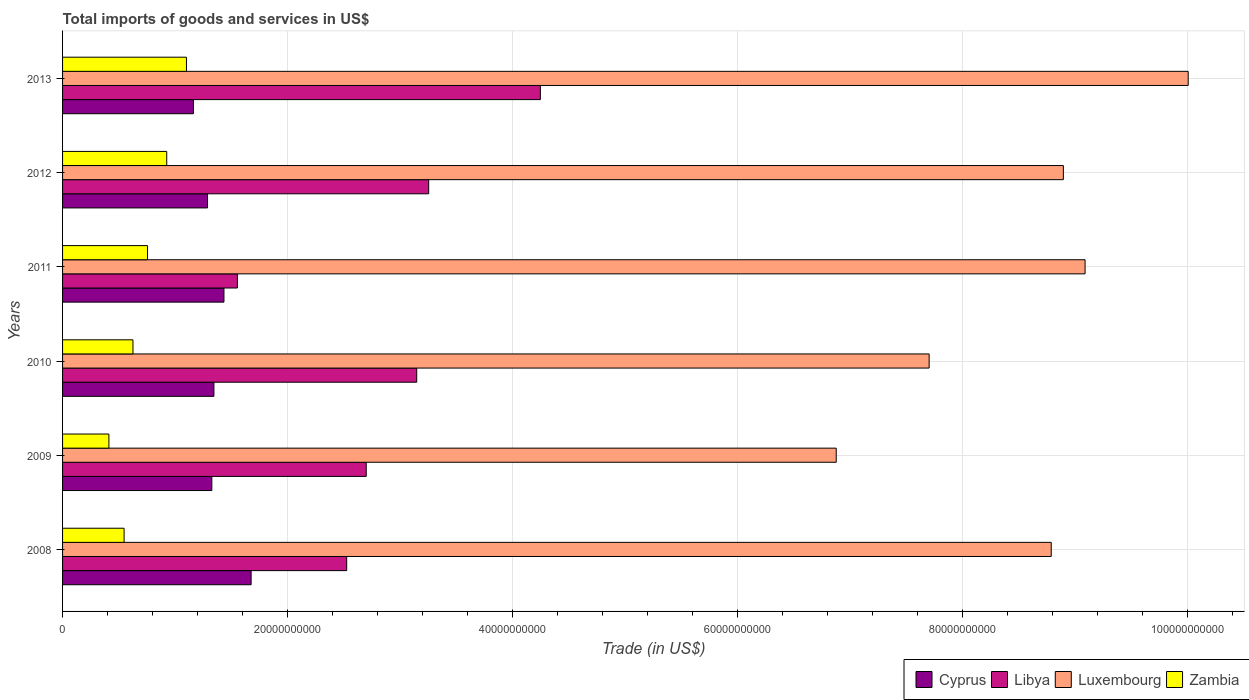Are the number of bars per tick equal to the number of legend labels?
Offer a terse response. Yes. Are the number of bars on each tick of the Y-axis equal?
Provide a succinct answer. Yes. How many bars are there on the 3rd tick from the top?
Provide a succinct answer. 4. In how many cases, is the number of bars for a given year not equal to the number of legend labels?
Offer a very short reply. 0. What is the total imports of goods and services in Luxembourg in 2008?
Give a very brief answer. 8.79e+1. Across all years, what is the maximum total imports of goods and services in Luxembourg?
Provide a short and direct response. 1.00e+11. Across all years, what is the minimum total imports of goods and services in Luxembourg?
Ensure brevity in your answer.  6.88e+1. What is the total total imports of goods and services in Libya in the graph?
Offer a very short reply. 1.74e+11. What is the difference between the total imports of goods and services in Zambia in 2010 and that in 2012?
Offer a very short reply. -3.00e+09. What is the difference between the total imports of goods and services in Luxembourg in 2008 and the total imports of goods and services in Cyprus in 2013?
Give a very brief answer. 7.62e+1. What is the average total imports of goods and services in Cyprus per year?
Offer a very short reply. 1.37e+1. In the year 2011, what is the difference between the total imports of goods and services in Zambia and total imports of goods and services in Cyprus?
Provide a short and direct response. -6.79e+09. What is the ratio of the total imports of goods and services in Luxembourg in 2008 to that in 2011?
Give a very brief answer. 0.97. Is the difference between the total imports of goods and services in Zambia in 2011 and 2012 greater than the difference between the total imports of goods and services in Cyprus in 2011 and 2012?
Your answer should be very brief. No. What is the difference between the highest and the second highest total imports of goods and services in Cyprus?
Give a very brief answer. 2.41e+09. What is the difference between the highest and the lowest total imports of goods and services in Libya?
Keep it short and to the point. 2.69e+1. In how many years, is the total imports of goods and services in Luxembourg greater than the average total imports of goods and services in Luxembourg taken over all years?
Give a very brief answer. 4. What does the 4th bar from the top in 2008 represents?
Offer a terse response. Cyprus. What does the 2nd bar from the bottom in 2013 represents?
Make the answer very short. Libya. Is it the case that in every year, the sum of the total imports of goods and services in Libya and total imports of goods and services in Luxembourg is greater than the total imports of goods and services in Zambia?
Your answer should be compact. Yes. How many bars are there?
Your answer should be compact. 24. Are all the bars in the graph horizontal?
Provide a short and direct response. Yes. What is the difference between two consecutive major ticks on the X-axis?
Give a very brief answer. 2.00e+1. Does the graph contain any zero values?
Offer a very short reply. No. Does the graph contain grids?
Ensure brevity in your answer.  Yes. How are the legend labels stacked?
Provide a short and direct response. Horizontal. What is the title of the graph?
Provide a short and direct response. Total imports of goods and services in US$. What is the label or title of the X-axis?
Your answer should be compact. Trade (in US$). What is the label or title of the Y-axis?
Give a very brief answer. Years. What is the Trade (in US$) in Cyprus in 2008?
Offer a very short reply. 1.68e+1. What is the Trade (in US$) of Libya in 2008?
Make the answer very short. 2.53e+1. What is the Trade (in US$) of Luxembourg in 2008?
Your response must be concise. 8.79e+1. What is the Trade (in US$) in Zambia in 2008?
Keep it short and to the point. 5.47e+09. What is the Trade (in US$) in Cyprus in 2009?
Ensure brevity in your answer.  1.33e+1. What is the Trade (in US$) in Libya in 2009?
Provide a short and direct response. 2.70e+1. What is the Trade (in US$) in Luxembourg in 2009?
Your response must be concise. 6.88e+1. What is the Trade (in US$) of Zambia in 2009?
Make the answer very short. 4.12e+09. What is the Trade (in US$) of Cyprus in 2010?
Provide a short and direct response. 1.35e+1. What is the Trade (in US$) in Libya in 2010?
Offer a very short reply. 3.15e+1. What is the Trade (in US$) of Luxembourg in 2010?
Your response must be concise. 7.70e+1. What is the Trade (in US$) of Zambia in 2010?
Provide a short and direct response. 6.26e+09. What is the Trade (in US$) of Cyprus in 2011?
Make the answer very short. 1.43e+1. What is the Trade (in US$) of Libya in 2011?
Your answer should be compact. 1.55e+1. What is the Trade (in US$) in Luxembourg in 2011?
Your answer should be compact. 9.09e+1. What is the Trade (in US$) in Zambia in 2011?
Keep it short and to the point. 7.55e+09. What is the Trade (in US$) in Cyprus in 2012?
Provide a succinct answer. 1.29e+1. What is the Trade (in US$) in Libya in 2012?
Offer a very short reply. 3.25e+1. What is the Trade (in US$) in Luxembourg in 2012?
Provide a succinct answer. 8.90e+1. What is the Trade (in US$) of Zambia in 2012?
Your response must be concise. 9.26e+09. What is the Trade (in US$) of Cyprus in 2013?
Offer a terse response. 1.16e+1. What is the Trade (in US$) of Libya in 2013?
Provide a succinct answer. 4.25e+1. What is the Trade (in US$) of Luxembourg in 2013?
Ensure brevity in your answer.  1.00e+11. What is the Trade (in US$) in Zambia in 2013?
Offer a very short reply. 1.10e+1. Across all years, what is the maximum Trade (in US$) of Cyprus?
Keep it short and to the point. 1.68e+1. Across all years, what is the maximum Trade (in US$) in Libya?
Your answer should be very brief. 4.25e+1. Across all years, what is the maximum Trade (in US$) of Luxembourg?
Make the answer very short. 1.00e+11. Across all years, what is the maximum Trade (in US$) in Zambia?
Make the answer very short. 1.10e+1. Across all years, what is the minimum Trade (in US$) in Cyprus?
Your answer should be compact. 1.16e+1. Across all years, what is the minimum Trade (in US$) of Libya?
Offer a terse response. 1.55e+1. Across all years, what is the minimum Trade (in US$) in Luxembourg?
Offer a terse response. 6.88e+1. Across all years, what is the minimum Trade (in US$) in Zambia?
Your answer should be compact. 4.12e+09. What is the total Trade (in US$) in Cyprus in the graph?
Your response must be concise. 8.23e+1. What is the total Trade (in US$) of Libya in the graph?
Provide a short and direct response. 1.74e+11. What is the total Trade (in US$) of Luxembourg in the graph?
Offer a very short reply. 5.14e+11. What is the total Trade (in US$) in Zambia in the graph?
Offer a terse response. 4.37e+1. What is the difference between the Trade (in US$) in Cyprus in 2008 and that in 2009?
Your answer should be compact. 3.49e+09. What is the difference between the Trade (in US$) of Libya in 2008 and that in 2009?
Provide a short and direct response. -1.74e+09. What is the difference between the Trade (in US$) in Luxembourg in 2008 and that in 2009?
Provide a succinct answer. 1.91e+1. What is the difference between the Trade (in US$) in Zambia in 2008 and that in 2009?
Your answer should be compact. 1.35e+09. What is the difference between the Trade (in US$) of Cyprus in 2008 and that in 2010?
Your answer should be very brief. 3.31e+09. What is the difference between the Trade (in US$) of Libya in 2008 and that in 2010?
Make the answer very short. -6.22e+09. What is the difference between the Trade (in US$) of Luxembourg in 2008 and that in 2010?
Your answer should be compact. 1.09e+1. What is the difference between the Trade (in US$) in Zambia in 2008 and that in 2010?
Your answer should be very brief. -7.88e+08. What is the difference between the Trade (in US$) in Cyprus in 2008 and that in 2011?
Offer a terse response. 2.41e+09. What is the difference between the Trade (in US$) in Libya in 2008 and that in 2011?
Provide a succinct answer. 9.71e+09. What is the difference between the Trade (in US$) of Luxembourg in 2008 and that in 2011?
Offer a very short reply. -3.01e+09. What is the difference between the Trade (in US$) in Zambia in 2008 and that in 2011?
Ensure brevity in your answer.  -2.08e+09. What is the difference between the Trade (in US$) of Cyprus in 2008 and that in 2012?
Your answer should be very brief. 3.87e+09. What is the difference between the Trade (in US$) of Libya in 2008 and that in 2012?
Give a very brief answer. -7.29e+09. What is the difference between the Trade (in US$) of Luxembourg in 2008 and that in 2012?
Offer a terse response. -1.08e+09. What is the difference between the Trade (in US$) in Zambia in 2008 and that in 2012?
Give a very brief answer. -3.79e+09. What is the difference between the Trade (in US$) of Cyprus in 2008 and that in 2013?
Your answer should be very brief. 5.13e+09. What is the difference between the Trade (in US$) of Libya in 2008 and that in 2013?
Your response must be concise. -1.72e+1. What is the difference between the Trade (in US$) of Luxembourg in 2008 and that in 2013?
Keep it short and to the point. -1.22e+1. What is the difference between the Trade (in US$) of Zambia in 2008 and that in 2013?
Your answer should be very brief. -5.54e+09. What is the difference between the Trade (in US$) of Cyprus in 2009 and that in 2010?
Make the answer very short. -1.86e+08. What is the difference between the Trade (in US$) of Libya in 2009 and that in 2010?
Provide a succinct answer. -4.49e+09. What is the difference between the Trade (in US$) of Luxembourg in 2009 and that in 2010?
Provide a short and direct response. -8.26e+09. What is the difference between the Trade (in US$) of Zambia in 2009 and that in 2010?
Keep it short and to the point. -2.14e+09. What is the difference between the Trade (in US$) of Cyprus in 2009 and that in 2011?
Offer a very short reply. -1.08e+09. What is the difference between the Trade (in US$) of Libya in 2009 and that in 2011?
Your answer should be compact. 1.14e+1. What is the difference between the Trade (in US$) of Luxembourg in 2009 and that in 2011?
Provide a succinct answer. -2.21e+1. What is the difference between the Trade (in US$) of Zambia in 2009 and that in 2011?
Offer a terse response. -3.43e+09. What is the difference between the Trade (in US$) of Cyprus in 2009 and that in 2012?
Ensure brevity in your answer.  3.82e+08. What is the difference between the Trade (in US$) of Libya in 2009 and that in 2012?
Provide a short and direct response. -5.55e+09. What is the difference between the Trade (in US$) of Luxembourg in 2009 and that in 2012?
Offer a terse response. -2.02e+1. What is the difference between the Trade (in US$) of Zambia in 2009 and that in 2012?
Give a very brief answer. -5.14e+09. What is the difference between the Trade (in US$) in Cyprus in 2009 and that in 2013?
Provide a short and direct response. 1.64e+09. What is the difference between the Trade (in US$) of Libya in 2009 and that in 2013?
Offer a terse response. -1.55e+1. What is the difference between the Trade (in US$) in Luxembourg in 2009 and that in 2013?
Your response must be concise. -3.13e+1. What is the difference between the Trade (in US$) of Zambia in 2009 and that in 2013?
Offer a terse response. -6.89e+09. What is the difference between the Trade (in US$) in Cyprus in 2010 and that in 2011?
Your response must be concise. -8.92e+08. What is the difference between the Trade (in US$) in Libya in 2010 and that in 2011?
Keep it short and to the point. 1.59e+1. What is the difference between the Trade (in US$) of Luxembourg in 2010 and that in 2011?
Ensure brevity in your answer.  -1.39e+1. What is the difference between the Trade (in US$) in Zambia in 2010 and that in 2011?
Provide a short and direct response. -1.30e+09. What is the difference between the Trade (in US$) of Cyprus in 2010 and that in 2012?
Your response must be concise. 5.68e+08. What is the difference between the Trade (in US$) in Libya in 2010 and that in 2012?
Provide a short and direct response. -1.06e+09. What is the difference between the Trade (in US$) in Luxembourg in 2010 and that in 2012?
Your answer should be very brief. -1.19e+1. What is the difference between the Trade (in US$) of Zambia in 2010 and that in 2012?
Give a very brief answer. -3.00e+09. What is the difference between the Trade (in US$) of Cyprus in 2010 and that in 2013?
Make the answer very short. 1.82e+09. What is the difference between the Trade (in US$) in Libya in 2010 and that in 2013?
Your answer should be compact. -1.10e+1. What is the difference between the Trade (in US$) of Luxembourg in 2010 and that in 2013?
Offer a terse response. -2.30e+1. What is the difference between the Trade (in US$) in Zambia in 2010 and that in 2013?
Keep it short and to the point. -4.75e+09. What is the difference between the Trade (in US$) of Cyprus in 2011 and that in 2012?
Keep it short and to the point. 1.46e+09. What is the difference between the Trade (in US$) of Libya in 2011 and that in 2012?
Offer a very short reply. -1.70e+1. What is the difference between the Trade (in US$) of Luxembourg in 2011 and that in 2012?
Offer a very short reply. 1.93e+09. What is the difference between the Trade (in US$) in Zambia in 2011 and that in 2012?
Make the answer very short. -1.71e+09. What is the difference between the Trade (in US$) in Cyprus in 2011 and that in 2013?
Ensure brevity in your answer.  2.71e+09. What is the difference between the Trade (in US$) of Libya in 2011 and that in 2013?
Your answer should be compact. -2.69e+1. What is the difference between the Trade (in US$) in Luxembourg in 2011 and that in 2013?
Your answer should be very brief. -9.17e+09. What is the difference between the Trade (in US$) in Zambia in 2011 and that in 2013?
Your answer should be very brief. -3.46e+09. What is the difference between the Trade (in US$) in Cyprus in 2012 and that in 2013?
Provide a succinct answer. 1.25e+09. What is the difference between the Trade (in US$) in Libya in 2012 and that in 2013?
Your answer should be compact. -9.93e+09. What is the difference between the Trade (in US$) of Luxembourg in 2012 and that in 2013?
Provide a succinct answer. -1.11e+1. What is the difference between the Trade (in US$) of Zambia in 2012 and that in 2013?
Keep it short and to the point. -1.75e+09. What is the difference between the Trade (in US$) in Cyprus in 2008 and the Trade (in US$) in Libya in 2009?
Your response must be concise. -1.02e+1. What is the difference between the Trade (in US$) in Cyprus in 2008 and the Trade (in US$) in Luxembourg in 2009?
Provide a short and direct response. -5.20e+1. What is the difference between the Trade (in US$) in Cyprus in 2008 and the Trade (in US$) in Zambia in 2009?
Your answer should be very brief. 1.26e+1. What is the difference between the Trade (in US$) of Libya in 2008 and the Trade (in US$) of Luxembourg in 2009?
Give a very brief answer. -4.35e+1. What is the difference between the Trade (in US$) in Libya in 2008 and the Trade (in US$) in Zambia in 2009?
Give a very brief answer. 2.11e+1. What is the difference between the Trade (in US$) in Luxembourg in 2008 and the Trade (in US$) in Zambia in 2009?
Keep it short and to the point. 8.38e+1. What is the difference between the Trade (in US$) in Cyprus in 2008 and the Trade (in US$) in Libya in 2010?
Your response must be concise. -1.47e+1. What is the difference between the Trade (in US$) in Cyprus in 2008 and the Trade (in US$) in Luxembourg in 2010?
Your response must be concise. -6.03e+1. What is the difference between the Trade (in US$) of Cyprus in 2008 and the Trade (in US$) of Zambia in 2010?
Your answer should be very brief. 1.05e+1. What is the difference between the Trade (in US$) in Libya in 2008 and the Trade (in US$) in Luxembourg in 2010?
Your answer should be very brief. -5.18e+1. What is the difference between the Trade (in US$) in Libya in 2008 and the Trade (in US$) in Zambia in 2010?
Ensure brevity in your answer.  1.90e+1. What is the difference between the Trade (in US$) in Luxembourg in 2008 and the Trade (in US$) in Zambia in 2010?
Offer a terse response. 8.16e+1. What is the difference between the Trade (in US$) of Cyprus in 2008 and the Trade (in US$) of Libya in 2011?
Your answer should be very brief. 1.22e+09. What is the difference between the Trade (in US$) in Cyprus in 2008 and the Trade (in US$) in Luxembourg in 2011?
Provide a succinct answer. -7.41e+1. What is the difference between the Trade (in US$) of Cyprus in 2008 and the Trade (in US$) of Zambia in 2011?
Offer a very short reply. 9.21e+09. What is the difference between the Trade (in US$) of Libya in 2008 and the Trade (in US$) of Luxembourg in 2011?
Your answer should be compact. -6.56e+1. What is the difference between the Trade (in US$) of Libya in 2008 and the Trade (in US$) of Zambia in 2011?
Provide a succinct answer. 1.77e+1. What is the difference between the Trade (in US$) in Luxembourg in 2008 and the Trade (in US$) in Zambia in 2011?
Your answer should be compact. 8.03e+1. What is the difference between the Trade (in US$) of Cyprus in 2008 and the Trade (in US$) of Libya in 2012?
Offer a very short reply. -1.58e+1. What is the difference between the Trade (in US$) of Cyprus in 2008 and the Trade (in US$) of Luxembourg in 2012?
Keep it short and to the point. -7.22e+1. What is the difference between the Trade (in US$) of Cyprus in 2008 and the Trade (in US$) of Zambia in 2012?
Provide a short and direct response. 7.50e+09. What is the difference between the Trade (in US$) in Libya in 2008 and the Trade (in US$) in Luxembourg in 2012?
Offer a very short reply. -6.37e+1. What is the difference between the Trade (in US$) of Libya in 2008 and the Trade (in US$) of Zambia in 2012?
Keep it short and to the point. 1.60e+1. What is the difference between the Trade (in US$) of Luxembourg in 2008 and the Trade (in US$) of Zambia in 2012?
Give a very brief answer. 7.86e+1. What is the difference between the Trade (in US$) of Cyprus in 2008 and the Trade (in US$) of Libya in 2013?
Offer a terse response. -2.57e+1. What is the difference between the Trade (in US$) in Cyprus in 2008 and the Trade (in US$) in Luxembourg in 2013?
Keep it short and to the point. -8.33e+1. What is the difference between the Trade (in US$) of Cyprus in 2008 and the Trade (in US$) of Zambia in 2013?
Ensure brevity in your answer.  5.75e+09. What is the difference between the Trade (in US$) of Libya in 2008 and the Trade (in US$) of Luxembourg in 2013?
Your answer should be compact. -7.48e+1. What is the difference between the Trade (in US$) of Libya in 2008 and the Trade (in US$) of Zambia in 2013?
Give a very brief answer. 1.42e+1. What is the difference between the Trade (in US$) of Luxembourg in 2008 and the Trade (in US$) of Zambia in 2013?
Offer a very short reply. 7.69e+1. What is the difference between the Trade (in US$) of Cyprus in 2009 and the Trade (in US$) of Libya in 2010?
Provide a succinct answer. -1.82e+1. What is the difference between the Trade (in US$) in Cyprus in 2009 and the Trade (in US$) in Luxembourg in 2010?
Give a very brief answer. -6.38e+1. What is the difference between the Trade (in US$) in Cyprus in 2009 and the Trade (in US$) in Zambia in 2010?
Give a very brief answer. 7.01e+09. What is the difference between the Trade (in US$) of Libya in 2009 and the Trade (in US$) of Luxembourg in 2010?
Offer a very short reply. -5.00e+1. What is the difference between the Trade (in US$) of Libya in 2009 and the Trade (in US$) of Zambia in 2010?
Your answer should be very brief. 2.07e+1. What is the difference between the Trade (in US$) in Luxembourg in 2009 and the Trade (in US$) in Zambia in 2010?
Provide a succinct answer. 6.25e+1. What is the difference between the Trade (in US$) of Cyprus in 2009 and the Trade (in US$) of Libya in 2011?
Your answer should be very brief. -2.28e+09. What is the difference between the Trade (in US$) in Cyprus in 2009 and the Trade (in US$) in Luxembourg in 2011?
Provide a succinct answer. -7.76e+1. What is the difference between the Trade (in US$) of Cyprus in 2009 and the Trade (in US$) of Zambia in 2011?
Provide a succinct answer. 5.71e+09. What is the difference between the Trade (in US$) of Libya in 2009 and the Trade (in US$) of Luxembourg in 2011?
Make the answer very short. -6.39e+1. What is the difference between the Trade (in US$) of Libya in 2009 and the Trade (in US$) of Zambia in 2011?
Provide a succinct answer. 1.94e+1. What is the difference between the Trade (in US$) in Luxembourg in 2009 and the Trade (in US$) in Zambia in 2011?
Offer a terse response. 6.12e+1. What is the difference between the Trade (in US$) of Cyprus in 2009 and the Trade (in US$) of Libya in 2012?
Keep it short and to the point. -1.93e+1. What is the difference between the Trade (in US$) of Cyprus in 2009 and the Trade (in US$) of Luxembourg in 2012?
Your response must be concise. -7.57e+1. What is the difference between the Trade (in US$) in Cyprus in 2009 and the Trade (in US$) in Zambia in 2012?
Provide a succinct answer. 4.01e+09. What is the difference between the Trade (in US$) in Libya in 2009 and the Trade (in US$) in Luxembourg in 2012?
Your answer should be compact. -6.20e+1. What is the difference between the Trade (in US$) of Libya in 2009 and the Trade (in US$) of Zambia in 2012?
Offer a very short reply. 1.77e+1. What is the difference between the Trade (in US$) of Luxembourg in 2009 and the Trade (in US$) of Zambia in 2012?
Provide a short and direct response. 5.95e+1. What is the difference between the Trade (in US$) in Cyprus in 2009 and the Trade (in US$) in Libya in 2013?
Your answer should be very brief. -2.92e+1. What is the difference between the Trade (in US$) of Cyprus in 2009 and the Trade (in US$) of Luxembourg in 2013?
Your response must be concise. -8.68e+1. What is the difference between the Trade (in US$) of Cyprus in 2009 and the Trade (in US$) of Zambia in 2013?
Your response must be concise. 2.26e+09. What is the difference between the Trade (in US$) of Libya in 2009 and the Trade (in US$) of Luxembourg in 2013?
Keep it short and to the point. -7.31e+1. What is the difference between the Trade (in US$) in Libya in 2009 and the Trade (in US$) in Zambia in 2013?
Provide a succinct answer. 1.60e+1. What is the difference between the Trade (in US$) of Luxembourg in 2009 and the Trade (in US$) of Zambia in 2013?
Make the answer very short. 5.78e+1. What is the difference between the Trade (in US$) of Cyprus in 2010 and the Trade (in US$) of Libya in 2011?
Provide a short and direct response. -2.09e+09. What is the difference between the Trade (in US$) in Cyprus in 2010 and the Trade (in US$) in Luxembourg in 2011?
Provide a succinct answer. -7.74e+1. What is the difference between the Trade (in US$) of Cyprus in 2010 and the Trade (in US$) of Zambia in 2011?
Provide a short and direct response. 5.90e+09. What is the difference between the Trade (in US$) in Libya in 2010 and the Trade (in US$) in Luxembourg in 2011?
Provide a short and direct response. -5.94e+1. What is the difference between the Trade (in US$) in Libya in 2010 and the Trade (in US$) in Zambia in 2011?
Ensure brevity in your answer.  2.39e+1. What is the difference between the Trade (in US$) of Luxembourg in 2010 and the Trade (in US$) of Zambia in 2011?
Provide a short and direct response. 6.95e+1. What is the difference between the Trade (in US$) of Cyprus in 2010 and the Trade (in US$) of Libya in 2012?
Give a very brief answer. -1.91e+1. What is the difference between the Trade (in US$) of Cyprus in 2010 and the Trade (in US$) of Luxembourg in 2012?
Give a very brief answer. -7.55e+1. What is the difference between the Trade (in US$) of Cyprus in 2010 and the Trade (in US$) of Zambia in 2012?
Offer a terse response. 4.19e+09. What is the difference between the Trade (in US$) in Libya in 2010 and the Trade (in US$) in Luxembourg in 2012?
Give a very brief answer. -5.75e+1. What is the difference between the Trade (in US$) in Libya in 2010 and the Trade (in US$) in Zambia in 2012?
Your answer should be compact. 2.22e+1. What is the difference between the Trade (in US$) of Luxembourg in 2010 and the Trade (in US$) of Zambia in 2012?
Offer a very short reply. 6.78e+1. What is the difference between the Trade (in US$) of Cyprus in 2010 and the Trade (in US$) of Libya in 2013?
Offer a terse response. -2.90e+1. What is the difference between the Trade (in US$) in Cyprus in 2010 and the Trade (in US$) in Luxembourg in 2013?
Ensure brevity in your answer.  -8.66e+1. What is the difference between the Trade (in US$) in Cyprus in 2010 and the Trade (in US$) in Zambia in 2013?
Your answer should be very brief. 2.44e+09. What is the difference between the Trade (in US$) of Libya in 2010 and the Trade (in US$) of Luxembourg in 2013?
Give a very brief answer. -6.86e+1. What is the difference between the Trade (in US$) of Libya in 2010 and the Trade (in US$) of Zambia in 2013?
Offer a very short reply. 2.05e+1. What is the difference between the Trade (in US$) of Luxembourg in 2010 and the Trade (in US$) of Zambia in 2013?
Your answer should be very brief. 6.60e+1. What is the difference between the Trade (in US$) of Cyprus in 2011 and the Trade (in US$) of Libya in 2012?
Provide a short and direct response. -1.82e+1. What is the difference between the Trade (in US$) of Cyprus in 2011 and the Trade (in US$) of Luxembourg in 2012?
Your answer should be very brief. -7.46e+1. What is the difference between the Trade (in US$) in Cyprus in 2011 and the Trade (in US$) in Zambia in 2012?
Keep it short and to the point. 5.09e+09. What is the difference between the Trade (in US$) in Libya in 2011 and the Trade (in US$) in Luxembourg in 2012?
Ensure brevity in your answer.  -7.34e+1. What is the difference between the Trade (in US$) of Libya in 2011 and the Trade (in US$) of Zambia in 2012?
Your answer should be compact. 6.28e+09. What is the difference between the Trade (in US$) of Luxembourg in 2011 and the Trade (in US$) of Zambia in 2012?
Provide a short and direct response. 8.16e+1. What is the difference between the Trade (in US$) of Cyprus in 2011 and the Trade (in US$) of Libya in 2013?
Your answer should be compact. -2.81e+1. What is the difference between the Trade (in US$) of Cyprus in 2011 and the Trade (in US$) of Luxembourg in 2013?
Offer a terse response. -8.57e+1. What is the difference between the Trade (in US$) in Cyprus in 2011 and the Trade (in US$) in Zambia in 2013?
Ensure brevity in your answer.  3.33e+09. What is the difference between the Trade (in US$) of Libya in 2011 and the Trade (in US$) of Luxembourg in 2013?
Offer a terse response. -8.45e+1. What is the difference between the Trade (in US$) of Libya in 2011 and the Trade (in US$) of Zambia in 2013?
Your answer should be very brief. 4.53e+09. What is the difference between the Trade (in US$) in Luxembourg in 2011 and the Trade (in US$) in Zambia in 2013?
Keep it short and to the point. 7.99e+1. What is the difference between the Trade (in US$) in Cyprus in 2012 and the Trade (in US$) in Libya in 2013?
Keep it short and to the point. -2.96e+1. What is the difference between the Trade (in US$) in Cyprus in 2012 and the Trade (in US$) in Luxembourg in 2013?
Offer a terse response. -8.72e+1. What is the difference between the Trade (in US$) in Cyprus in 2012 and the Trade (in US$) in Zambia in 2013?
Provide a short and direct response. 1.87e+09. What is the difference between the Trade (in US$) in Libya in 2012 and the Trade (in US$) in Luxembourg in 2013?
Your answer should be very brief. -6.75e+1. What is the difference between the Trade (in US$) in Libya in 2012 and the Trade (in US$) in Zambia in 2013?
Your answer should be compact. 2.15e+1. What is the difference between the Trade (in US$) in Luxembourg in 2012 and the Trade (in US$) in Zambia in 2013?
Provide a succinct answer. 7.79e+1. What is the average Trade (in US$) of Cyprus per year?
Make the answer very short. 1.37e+1. What is the average Trade (in US$) in Libya per year?
Ensure brevity in your answer.  2.90e+1. What is the average Trade (in US$) of Luxembourg per year?
Keep it short and to the point. 8.56e+1. What is the average Trade (in US$) in Zambia per year?
Offer a terse response. 7.28e+09. In the year 2008, what is the difference between the Trade (in US$) in Cyprus and Trade (in US$) in Libya?
Your response must be concise. -8.50e+09. In the year 2008, what is the difference between the Trade (in US$) in Cyprus and Trade (in US$) in Luxembourg?
Ensure brevity in your answer.  -7.11e+1. In the year 2008, what is the difference between the Trade (in US$) of Cyprus and Trade (in US$) of Zambia?
Provide a short and direct response. 1.13e+1. In the year 2008, what is the difference between the Trade (in US$) of Libya and Trade (in US$) of Luxembourg?
Your answer should be very brief. -6.26e+1. In the year 2008, what is the difference between the Trade (in US$) in Libya and Trade (in US$) in Zambia?
Offer a terse response. 1.98e+1. In the year 2008, what is the difference between the Trade (in US$) in Luxembourg and Trade (in US$) in Zambia?
Provide a short and direct response. 8.24e+1. In the year 2009, what is the difference between the Trade (in US$) of Cyprus and Trade (in US$) of Libya?
Give a very brief answer. -1.37e+1. In the year 2009, what is the difference between the Trade (in US$) of Cyprus and Trade (in US$) of Luxembourg?
Give a very brief answer. -5.55e+1. In the year 2009, what is the difference between the Trade (in US$) of Cyprus and Trade (in US$) of Zambia?
Provide a succinct answer. 9.15e+09. In the year 2009, what is the difference between the Trade (in US$) in Libya and Trade (in US$) in Luxembourg?
Provide a succinct answer. -4.18e+1. In the year 2009, what is the difference between the Trade (in US$) in Libya and Trade (in US$) in Zambia?
Keep it short and to the point. 2.29e+1. In the year 2009, what is the difference between the Trade (in US$) in Luxembourg and Trade (in US$) in Zambia?
Provide a short and direct response. 6.46e+1. In the year 2010, what is the difference between the Trade (in US$) of Cyprus and Trade (in US$) of Libya?
Ensure brevity in your answer.  -1.80e+1. In the year 2010, what is the difference between the Trade (in US$) in Cyprus and Trade (in US$) in Luxembourg?
Provide a succinct answer. -6.36e+1. In the year 2010, what is the difference between the Trade (in US$) of Cyprus and Trade (in US$) of Zambia?
Your answer should be compact. 7.20e+09. In the year 2010, what is the difference between the Trade (in US$) of Libya and Trade (in US$) of Luxembourg?
Your answer should be compact. -4.55e+1. In the year 2010, what is the difference between the Trade (in US$) in Libya and Trade (in US$) in Zambia?
Give a very brief answer. 2.52e+1. In the year 2010, what is the difference between the Trade (in US$) in Luxembourg and Trade (in US$) in Zambia?
Your response must be concise. 7.08e+1. In the year 2011, what is the difference between the Trade (in US$) in Cyprus and Trade (in US$) in Libya?
Ensure brevity in your answer.  -1.20e+09. In the year 2011, what is the difference between the Trade (in US$) in Cyprus and Trade (in US$) in Luxembourg?
Your response must be concise. -7.65e+1. In the year 2011, what is the difference between the Trade (in US$) of Cyprus and Trade (in US$) of Zambia?
Provide a succinct answer. 6.79e+09. In the year 2011, what is the difference between the Trade (in US$) in Libya and Trade (in US$) in Luxembourg?
Your answer should be compact. -7.53e+1. In the year 2011, what is the difference between the Trade (in US$) of Libya and Trade (in US$) of Zambia?
Give a very brief answer. 7.99e+09. In the year 2011, what is the difference between the Trade (in US$) of Luxembourg and Trade (in US$) of Zambia?
Your response must be concise. 8.33e+1. In the year 2012, what is the difference between the Trade (in US$) of Cyprus and Trade (in US$) of Libya?
Your response must be concise. -1.97e+1. In the year 2012, what is the difference between the Trade (in US$) in Cyprus and Trade (in US$) in Luxembourg?
Provide a succinct answer. -7.61e+1. In the year 2012, what is the difference between the Trade (in US$) of Cyprus and Trade (in US$) of Zambia?
Give a very brief answer. 3.63e+09. In the year 2012, what is the difference between the Trade (in US$) of Libya and Trade (in US$) of Luxembourg?
Offer a terse response. -5.64e+1. In the year 2012, what is the difference between the Trade (in US$) in Libya and Trade (in US$) in Zambia?
Offer a terse response. 2.33e+1. In the year 2012, what is the difference between the Trade (in US$) in Luxembourg and Trade (in US$) in Zambia?
Give a very brief answer. 7.97e+1. In the year 2013, what is the difference between the Trade (in US$) of Cyprus and Trade (in US$) of Libya?
Offer a very short reply. -3.08e+1. In the year 2013, what is the difference between the Trade (in US$) in Cyprus and Trade (in US$) in Luxembourg?
Provide a succinct answer. -8.84e+1. In the year 2013, what is the difference between the Trade (in US$) in Cyprus and Trade (in US$) in Zambia?
Provide a succinct answer. 6.19e+08. In the year 2013, what is the difference between the Trade (in US$) in Libya and Trade (in US$) in Luxembourg?
Offer a terse response. -5.76e+1. In the year 2013, what is the difference between the Trade (in US$) in Libya and Trade (in US$) in Zambia?
Your response must be concise. 3.15e+1. In the year 2013, what is the difference between the Trade (in US$) of Luxembourg and Trade (in US$) of Zambia?
Your response must be concise. 8.90e+1. What is the ratio of the Trade (in US$) of Cyprus in 2008 to that in 2009?
Offer a terse response. 1.26. What is the ratio of the Trade (in US$) of Libya in 2008 to that in 2009?
Offer a terse response. 0.94. What is the ratio of the Trade (in US$) in Luxembourg in 2008 to that in 2009?
Your answer should be compact. 1.28. What is the ratio of the Trade (in US$) in Zambia in 2008 to that in 2009?
Your answer should be very brief. 1.33. What is the ratio of the Trade (in US$) of Cyprus in 2008 to that in 2010?
Give a very brief answer. 1.25. What is the ratio of the Trade (in US$) of Libya in 2008 to that in 2010?
Make the answer very short. 0.8. What is the ratio of the Trade (in US$) in Luxembourg in 2008 to that in 2010?
Offer a very short reply. 1.14. What is the ratio of the Trade (in US$) in Zambia in 2008 to that in 2010?
Provide a short and direct response. 0.87. What is the ratio of the Trade (in US$) of Cyprus in 2008 to that in 2011?
Offer a very short reply. 1.17. What is the ratio of the Trade (in US$) of Libya in 2008 to that in 2011?
Make the answer very short. 1.62. What is the ratio of the Trade (in US$) in Luxembourg in 2008 to that in 2011?
Keep it short and to the point. 0.97. What is the ratio of the Trade (in US$) of Zambia in 2008 to that in 2011?
Offer a very short reply. 0.72. What is the ratio of the Trade (in US$) in Cyprus in 2008 to that in 2012?
Offer a very short reply. 1.3. What is the ratio of the Trade (in US$) of Libya in 2008 to that in 2012?
Provide a short and direct response. 0.78. What is the ratio of the Trade (in US$) of Luxembourg in 2008 to that in 2012?
Your response must be concise. 0.99. What is the ratio of the Trade (in US$) in Zambia in 2008 to that in 2012?
Your answer should be very brief. 0.59. What is the ratio of the Trade (in US$) in Cyprus in 2008 to that in 2013?
Offer a very short reply. 1.44. What is the ratio of the Trade (in US$) in Libya in 2008 to that in 2013?
Your answer should be compact. 0.59. What is the ratio of the Trade (in US$) in Luxembourg in 2008 to that in 2013?
Your response must be concise. 0.88. What is the ratio of the Trade (in US$) in Zambia in 2008 to that in 2013?
Offer a terse response. 0.5. What is the ratio of the Trade (in US$) in Cyprus in 2009 to that in 2010?
Provide a short and direct response. 0.99. What is the ratio of the Trade (in US$) of Libya in 2009 to that in 2010?
Your answer should be very brief. 0.86. What is the ratio of the Trade (in US$) of Luxembourg in 2009 to that in 2010?
Give a very brief answer. 0.89. What is the ratio of the Trade (in US$) in Zambia in 2009 to that in 2010?
Keep it short and to the point. 0.66. What is the ratio of the Trade (in US$) in Cyprus in 2009 to that in 2011?
Keep it short and to the point. 0.92. What is the ratio of the Trade (in US$) in Libya in 2009 to that in 2011?
Provide a short and direct response. 1.74. What is the ratio of the Trade (in US$) of Luxembourg in 2009 to that in 2011?
Ensure brevity in your answer.  0.76. What is the ratio of the Trade (in US$) of Zambia in 2009 to that in 2011?
Ensure brevity in your answer.  0.55. What is the ratio of the Trade (in US$) in Cyprus in 2009 to that in 2012?
Make the answer very short. 1.03. What is the ratio of the Trade (in US$) of Libya in 2009 to that in 2012?
Your answer should be compact. 0.83. What is the ratio of the Trade (in US$) in Luxembourg in 2009 to that in 2012?
Offer a very short reply. 0.77. What is the ratio of the Trade (in US$) of Zambia in 2009 to that in 2012?
Offer a terse response. 0.44. What is the ratio of the Trade (in US$) in Cyprus in 2009 to that in 2013?
Offer a terse response. 1.14. What is the ratio of the Trade (in US$) of Libya in 2009 to that in 2013?
Your answer should be compact. 0.64. What is the ratio of the Trade (in US$) in Luxembourg in 2009 to that in 2013?
Make the answer very short. 0.69. What is the ratio of the Trade (in US$) of Zambia in 2009 to that in 2013?
Your answer should be very brief. 0.37. What is the ratio of the Trade (in US$) of Cyprus in 2010 to that in 2011?
Provide a succinct answer. 0.94. What is the ratio of the Trade (in US$) in Libya in 2010 to that in 2011?
Provide a succinct answer. 2.03. What is the ratio of the Trade (in US$) in Luxembourg in 2010 to that in 2011?
Provide a short and direct response. 0.85. What is the ratio of the Trade (in US$) of Zambia in 2010 to that in 2011?
Your answer should be compact. 0.83. What is the ratio of the Trade (in US$) in Cyprus in 2010 to that in 2012?
Ensure brevity in your answer.  1.04. What is the ratio of the Trade (in US$) in Libya in 2010 to that in 2012?
Offer a terse response. 0.97. What is the ratio of the Trade (in US$) of Luxembourg in 2010 to that in 2012?
Your answer should be compact. 0.87. What is the ratio of the Trade (in US$) in Zambia in 2010 to that in 2012?
Offer a very short reply. 0.68. What is the ratio of the Trade (in US$) in Cyprus in 2010 to that in 2013?
Make the answer very short. 1.16. What is the ratio of the Trade (in US$) in Libya in 2010 to that in 2013?
Offer a very short reply. 0.74. What is the ratio of the Trade (in US$) in Luxembourg in 2010 to that in 2013?
Keep it short and to the point. 0.77. What is the ratio of the Trade (in US$) in Zambia in 2010 to that in 2013?
Make the answer very short. 0.57. What is the ratio of the Trade (in US$) in Cyprus in 2011 to that in 2012?
Provide a succinct answer. 1.11. What is the ratio of the Trade (in US$) of Libya in 2011 to that in 2012?
Give a very brief answer. 0.48. What is the ratio of the Trade (in US$) in Luxembourg in 2011 to that in 2012?
Offer a very short reply. 1.02. What is the ratio of the Trade (in US$) of Zambia in 2011 to that in 2012?
Offer a very short reply. 0.82. What is the ratio of the Trade (in US$) in Cyprus in 2011 to that in 2013?
Provide a short and direct response. 1.23. What is the ratio of the Trade (in US$) of Libya in 2011 to that in 2013?
Your response must be concise. 0.37. What is the ratio of the Trade (in US$) in Luxembourg in 2011 to that in 2013?
Give a very brief answer. 0.91. What is the ratio of the Trade (in US$) in Zambia in 2011 to that in 2013?
Give a very brief answer. 0.69. What is the ratio of the Trade (in US$) of Cyprus in 2012 to that in 2013?
Your response must be concise. 1.11. What is the ratio of the Trade (in US$) of Libya in 2012 to that in 2013?
Provide a short and direct response. 0.77. What is the ratio of the Trade (in US$) in Luxembourg in 2012 to that in 2013?
Offer a terse response. 0.89. What is the ratio of the Trade (in US$) in Zambia in 2012 to that in 2013?
Offer a very short reply. 0.84. What is the difference between the highest and the second highest Trade (in US$) in Cyprus?
Your response must be concise. 2.41e+09. What is the difference between the highest and the second highest Trade (in US$) in Libya?
Your answer should be compact. 9.93e+09. What is the difference between the highest and the second highest Trade (in US$) in Luxembourg?
Your answer should be very brief. 9.17e+09. What is the difference between the highest and the second highest Trade (in US$) of Zambia?
Ensure brevity in your answer.  1.75e+09. What is the difference between the highest and the lowest Trade (in US$) in Cyprus?
Provide a succinct answer. 5.13e+09. What is the difference between the highest and the lowest Trade (in US$) of Libya?
Keep it short and to the point. 2.69e+1. What is the difference between the highest and the lowest Trade (in US$) of Luxembourg?
Your answer should be compact. 3.13e+1. What is the difference between the highest and the lowest Trade (in US$) in Zambia?
Make the answer very short. 6.89e+09. 